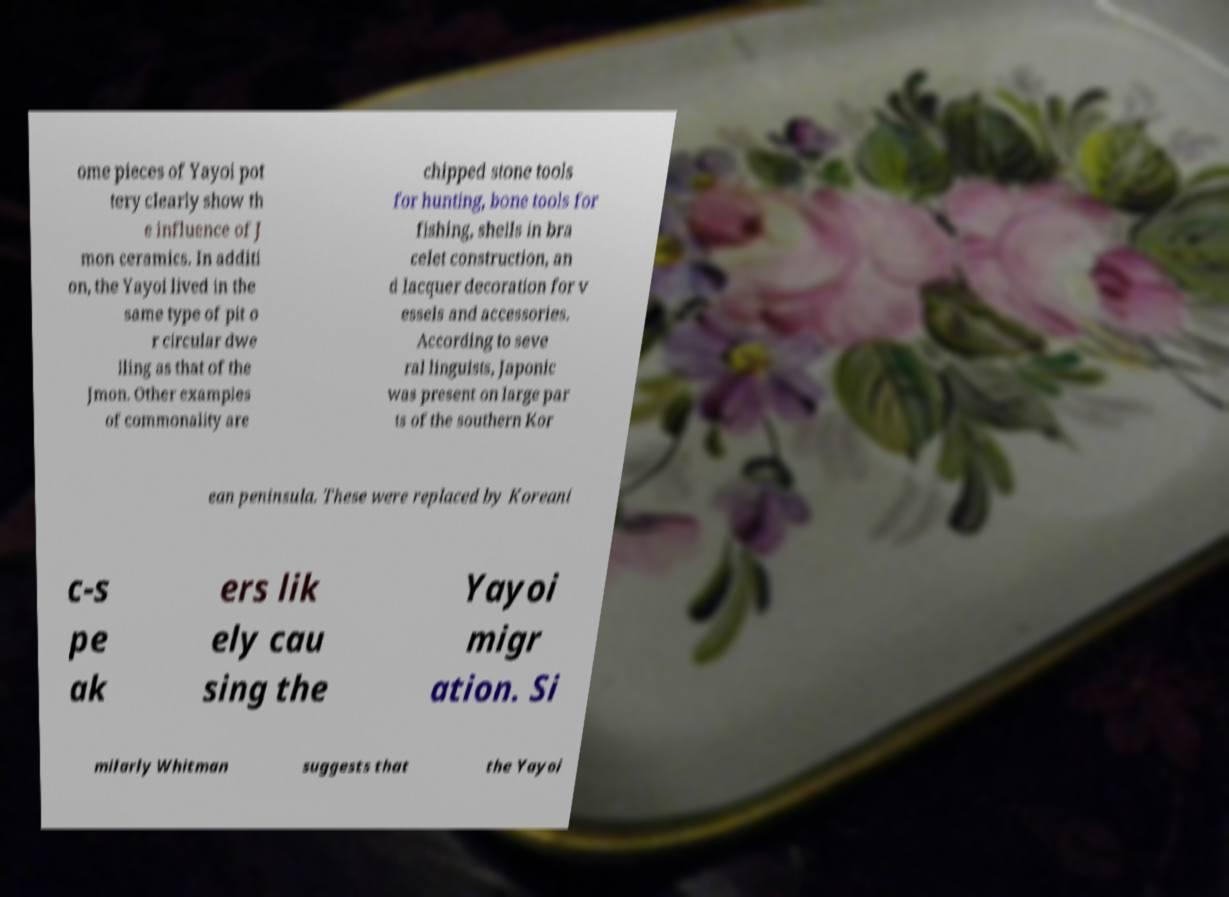What messages or text are displayed in this image? I need them in a readable, typed format. ome pieces of Yayoi pot tery clearly show th e influence of J mon ceramics. In additi on, the Yayoi lived in the same type of pit o r circular dwe lling as that of the Jmon. Other examples of commonality are chipped stone tools for hunting, bone tools for fishing, shells in bra celet construction, an d lacquer decoration for v essels and accessories. According to seve ral linguists, Japonic was present on large par ts of the southern Kor ean peninsula. These were replaced by Koreani c-s pe ak ers lik ely cau sing the Yayoi migr ation. Si milarly Whitman suggests that the Yayoi 